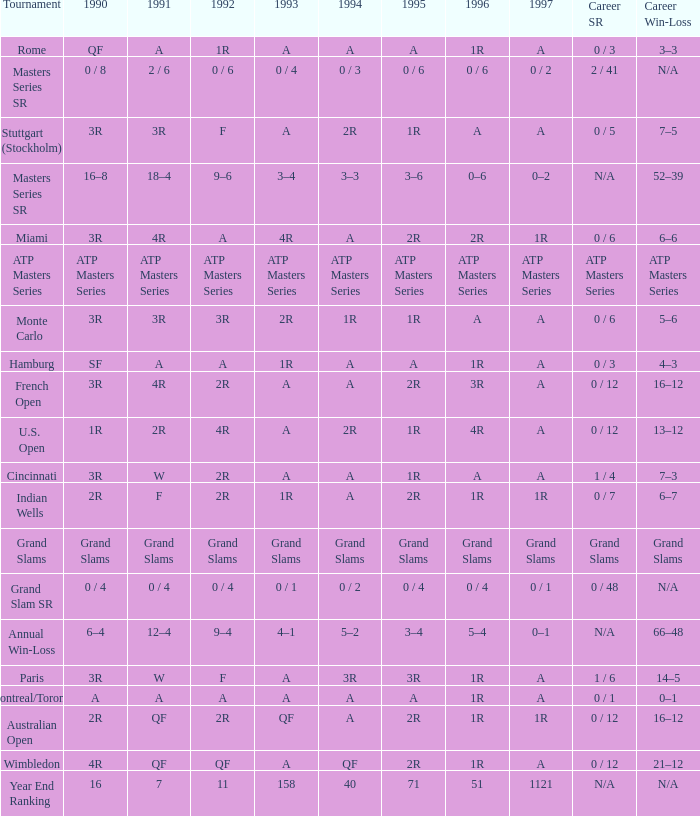What is 1997, when 1996 is "1R", when 1990 is "2R", and when 1991 is "F"? 1R. Can you parse all the data within this table? {'header': ['Tournament', '1990', '1991', '1992', '1993', '1994', '1995', '1996', '1997', 'Career SR', 'Career Win-Loss'], 'rows': [['Rome', 'QF', 'A', '1R', 'A', 'A', 'A', '1R', 'A', '0 / 3', '3–3'], ['Masters Series SR', '0 / 8', '2 / 6', '0 / 6', '0 / 4', '0 / 3', '0 / 6', '0 / 6', '0 / 2', '2 / 41', 'N/A'], ['Stuttgart (Stockholm)', '3R', '3R', 'F', 'A', '2R', '1R', 'A', 'A', '0 / 5', '7–5'], ['Masters Series SR', '16–8', '18–4', '9–6', '3–4', '3–3', '3–6', '0–6', '0–2', 'N/A', '52–39'], ['Miami', '3R', '4R', 'A', '4R', 'A', '2R', '2R', '1R', '0 / 6', '6–6'], ['ATP Masters Series', 'ATP Masters Series', 'ATP Masters Series', 'ATP Masters Series', 'ATP Masters Series', 'ATP Masters Series', 'ATP Masters Series', 'ATP Masters Series', 'ATP Masters Series', 'ATP Masters Series', 'ATP Masters Series'], ['Monte Carlo', '3R', '3R', '3R', '2R', '1R', '1R', 'A', 'A', '0 / 6', '5–6'], ['Hamburg', 'SF', 'A', 'A', '1R', 'A', 'A', '1R', 'A', '0 / 3', '4–3'], ['French Open', '3R', '4R', '2R', 'A', 'A', '2R', '3R', 'A', '0 / 12', '16–12'], ['U.S. Open', '1R', '2R', '4R', 'A', '2R', '1R', '4R', 'A', '0 / 12', '13–12'], ['Cincinnati', '3R', 'W', '2R', 'A', 'A', '1R', 'A', 'A', '1 / 4', '7–3'], ['Indian Wells', '2R', 'F', '2R', '1R', 'A', '2R', '1R', '1R', '0 / 7', '6–7'], ['Grand Slams', 'Grand Slams', 'Grand Slams', 'Grand Slams', 'Grand Slams', 'Grand Slams', 'Grand Slams', 'Grand Slams', 'Grand Slams', 'Grand Slams', 'Grand Slams'], ['Grand Slam SR', '0 / 4', '0 / 4', '0 / 4', '0 / 1', '0 / 2', '0 / 4', '0 / 4', '0 / 1', '0 / 48', 'N/A'], ['Annual Win-Loss', '6–4', '12–4', '9–4', '4–1', '5–2', '3–4', '5–4', '0–1', 'N/A', '66–48'], ['Paris', '3R', 'W', 'F', 'A', '3R', '3R', '1R', 'A', '1 / 6', '14–5'], ['Montreal/Toronto', 'A', 'A', 'A', 'A', 'A', 'A', '1R', 'A', '0 / 1', '0–1'], ['Australian Open', '2R', 'QF', '2R', 'QF', 'A', '2R', '1R', '1R', '0 / 12', '16–12'], ['Wimbledon', '4R', 'QF', 'QF', 'A', 'QF', '2R', '1R', 'A', '0 / 12', '21–12'], ['Year End Ranking', '16', '7', '11', '158', '40', '71', '51', '1121', 'N/A', 'N/A']]} 